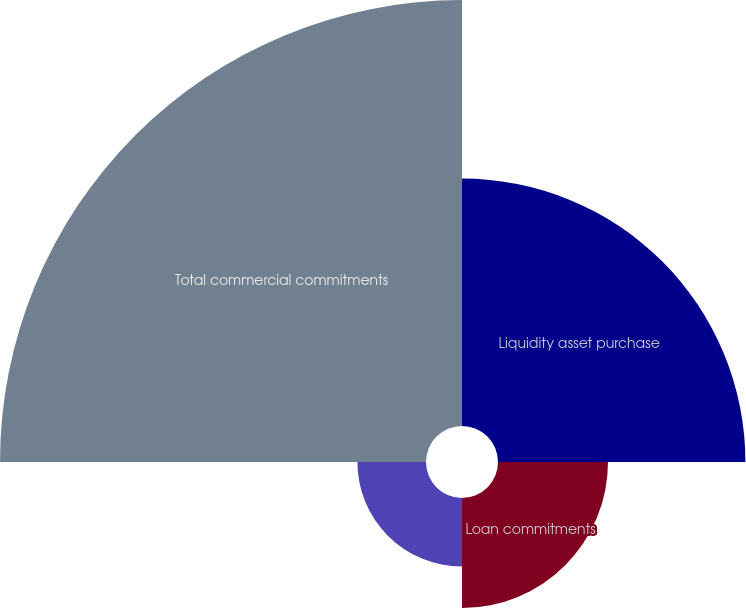<chart> <loc_0><loc_0><loc_500><loc_500><pie_chart><fcel>Liquidity asset purchase<fcel>Loan commitments<fcel>Standby letters of credit<fcel>Total commercial commitments<nl><fcel>29.04%<fcel>12.91%<fcel>8.05%<fcel>50.0%<nl></chart> 